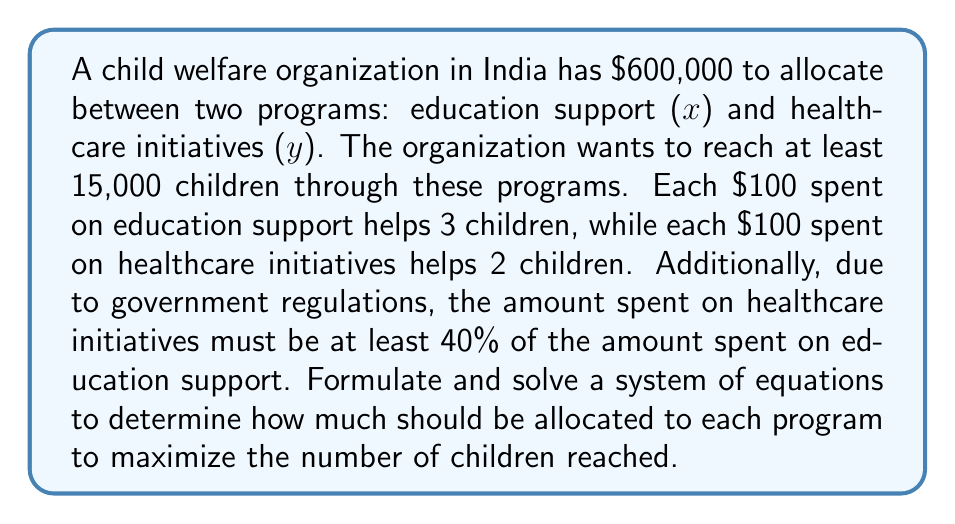What is the answer to this math problem? Let's approach this step-by-step:

1) First, let's define our variables:
   $x$ = amount spent on education support (in hundreds of dollars)
   $y$ = amount spent on healthcare initiatives (in hundreds of dollars)

2) Now, we can formulate our equations:

   Budget constraint: $x + y = 6000$ (as the total budget is $600,000)

   Minimum children reached: $3x + 2y \geq 15000$

   Government regulation: $y \geq 0.4x$

3) Our objective is to maximize $3x + 2y$ subject to these constraints.

4) From the government regulation, we know that $y = 0.4x$ at the minimum. Let's substitute this into our other equations:

   $x + 0.4x = 6000$
   $1.4x = 6000$
   $x = 4285.71$

   $3(4285.71) + 2(0.4 * 4285.71) \geq 15000$
   $12857.13 + 3428.57 = 16285.7 > 15000$

5) This solution satisfies all constraints and maximizes the number of children reached.

6) Therefore:
   Education support: $428,571
   Healthcare initiatives: $171,429

7) We can verify:
   Total budget: $428,571 + $171,429 = $600,000
   Children reached: (428,571 / 100 * 3) + (171,429 / 100 * 2) = 12,857 + 3,429 = 16,286
Answer: Education support: $428,571; Healthcare initiatives: $171,429 